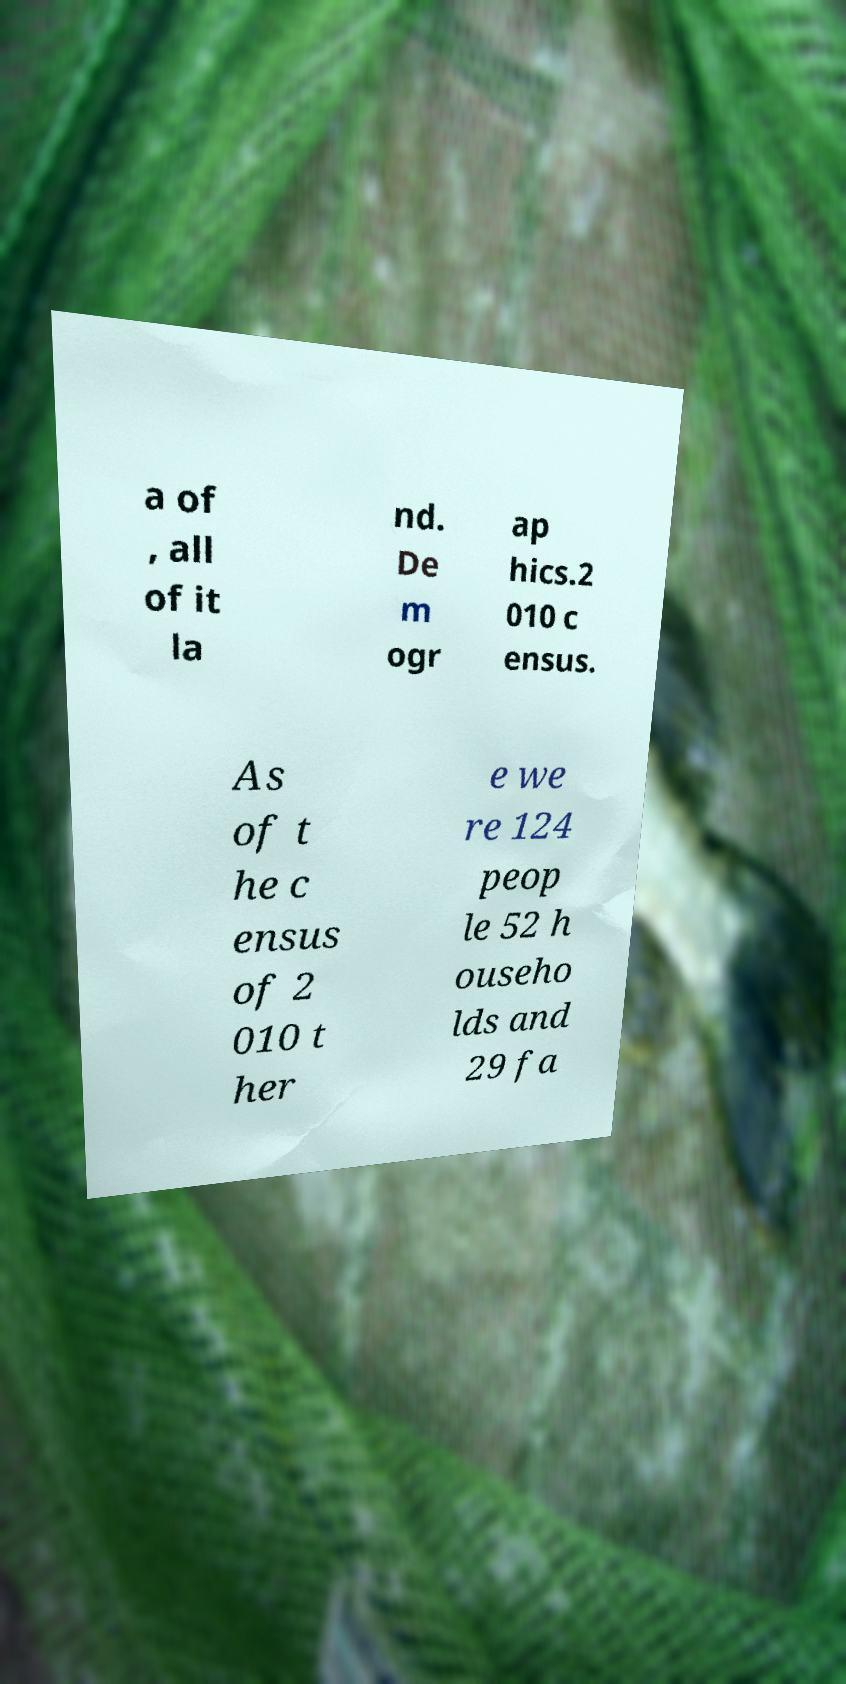Please read and relay the text visible in this image. What does it say? a of , all of it la nd. De m ogr ap hics.2 010 c ensus. As of t he c ensus of 2 010 t her e we re 124 peop le 52 h ouseho lds and 29 fa 